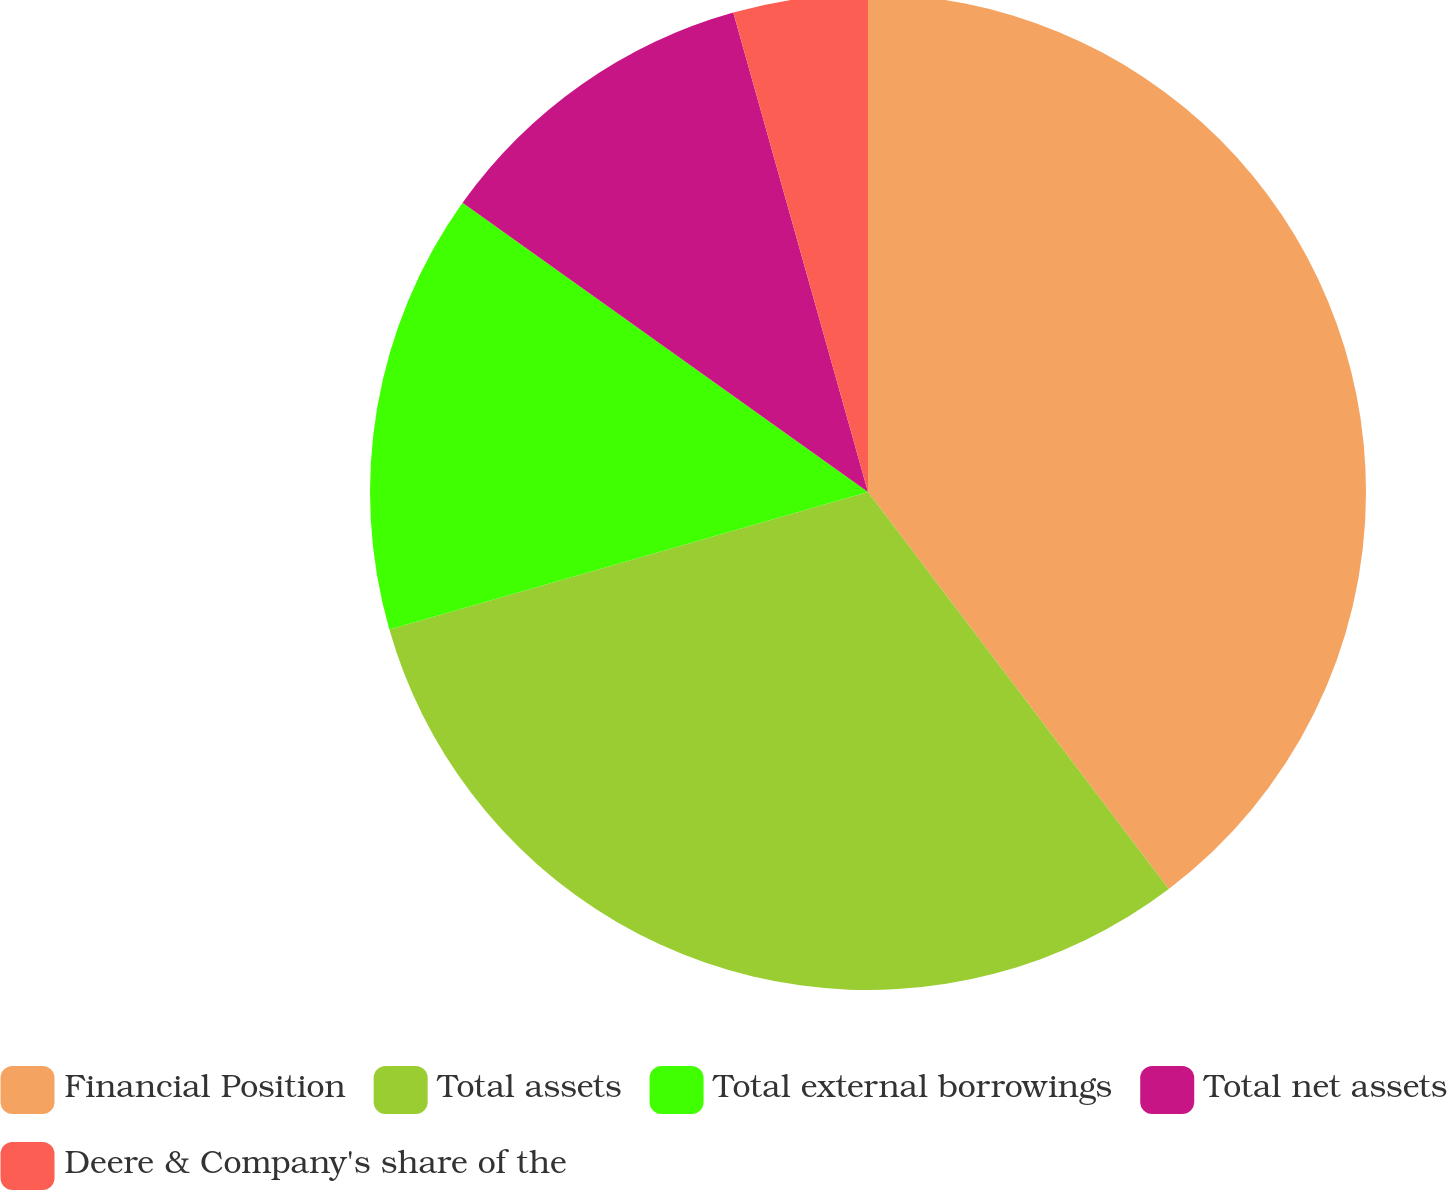Convert chart. <chart><loc_0><loc_0><loc_500><loc_500><pie_chart><fcel>Financial Position<fcel>Total assets<fcel>Total external borrowings<fcel>Total net assets<fcel>Deere & Company's share of the<nl><fcel>39.68%<fcel>30.87%<fcel>14.31%<fcel>10.78%<fcel>4.36%<nl></chart> 